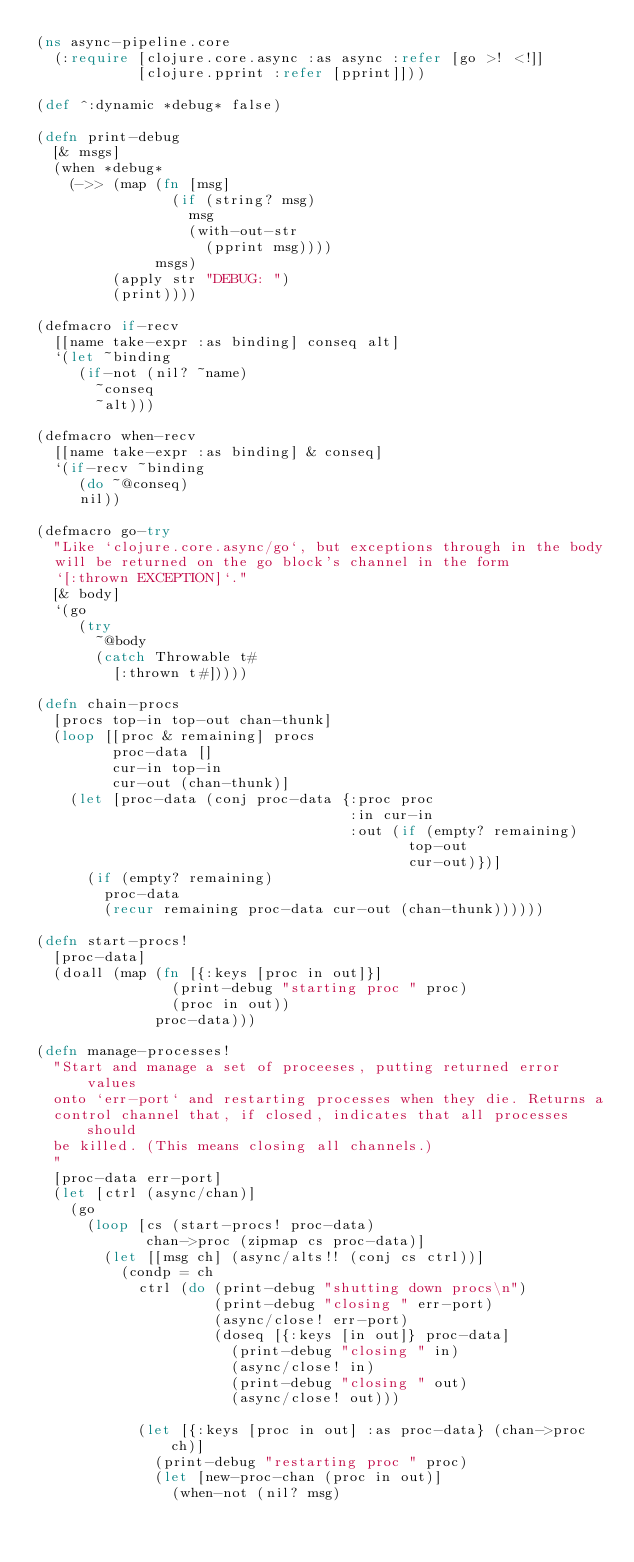<code> <loc_0><loc_0><loc_500><loc_500><_Clojure_>(ns async-pipeline.core
  (:require [clojure.core.async :as async :refer [go >! <!]]
            [clojure.pprint :refer [pprint]]))

(def ^:dynamic *debug* false)

(defn print-debug
  [& msgs]
  (when *debug*
    (->> (map (fn [msg]
                (if (string? msg)
                  msg
                  (with-out-str
                    (pprint msg))))
              msgs)
         (apply str "DEBUG: ")
         (print))))

(defmacro if-recv
  [[name take-expr :as binding] conseq alt]
  `(let ~binding
     (if-not (nil? ~name)
       ~conseq
       ~alt)))

(defmacro when-recv
  [[name take-expr :as binding] & conseq]
  `(if-recv ~binding
     (do ~@conseq)
     nil))

(defmacro go-try
  "Like `clojure.core.async/go`, but exceptions through in the body
  will be returned on the go block's channel in the form
  `[:thrown EXCEPTION]`."
  [& body]
  `(go
     (try
       ~@body
       (catch Throwable t#
         [:thrown t#]))))

(defn chain-procs
  [procs top-in top-out chan-thunk]
  (loop [[proc & remaining] procs
         proc-data []
         cur-in top-in
         cur-out (chan-thunk)]
    (let [proc-data (conj proc-data {:proc proc
                                     :in cur-in
                                     :out (if (empty? remaining)
                                            top-out
                                            cur-out)})]
      (if (empty? remaining)
        proc-data
        (recur remaining proc-data cur-out (chan-thunk))))))

(defn start-procs!
  [proc-data]
  (doall (map (fn [{:keys [proc in out]}]
                (print-debug "starting proc " proc)
                (proc in out))
              proc-data)))

(defn manage-processes!
  "Start and manage a set of proceeses, putting returned error values
  onto `err-port` and restarting processes when they die. Returns a
  control channel that, if closed, indicates that all processes should
  be killed. (This means closing all channels.)
  "
  [proc-data err-port]
  (let [ctrl (async/chan)]
    (go
      (loop [cs (start-procs! proc-data)
             chan->proc (zipmap cs proc-data)]
        (let [[msg ch] (async/alts!! (conj cs ctrl))]
          (condp = ch
            ctrl (do (print-debug "shutting down procs\n")
                     (print-debug "closing " err-port)
                     (async/close! err-port)
                     (doseq [{:keys [in out]} proc-data]
                       (print-debug "closing " in)
                       (async/close! in)
                       (print-debug "closing " out)
                       (async/close! out)))

            (let [{:keys [proc in out] :as proc-data} (chan->proc ch)]
              (print-debug "restarting proc " proc)
              (let [new-proc-chan (proc in out)]
                (when-not (nil? msg)</code> 